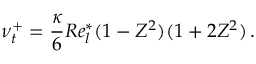<formula> <loc_0><loc_0><loc_500><loc_500>\nu _ { t } ^ { + } = \frac { \kappa } { 6 } R e _ { l } ^ { * } ( 1 - Z ^ { 2 } ) ( 1 + 2 Z ^ { 2 } ) \, .</formula> 